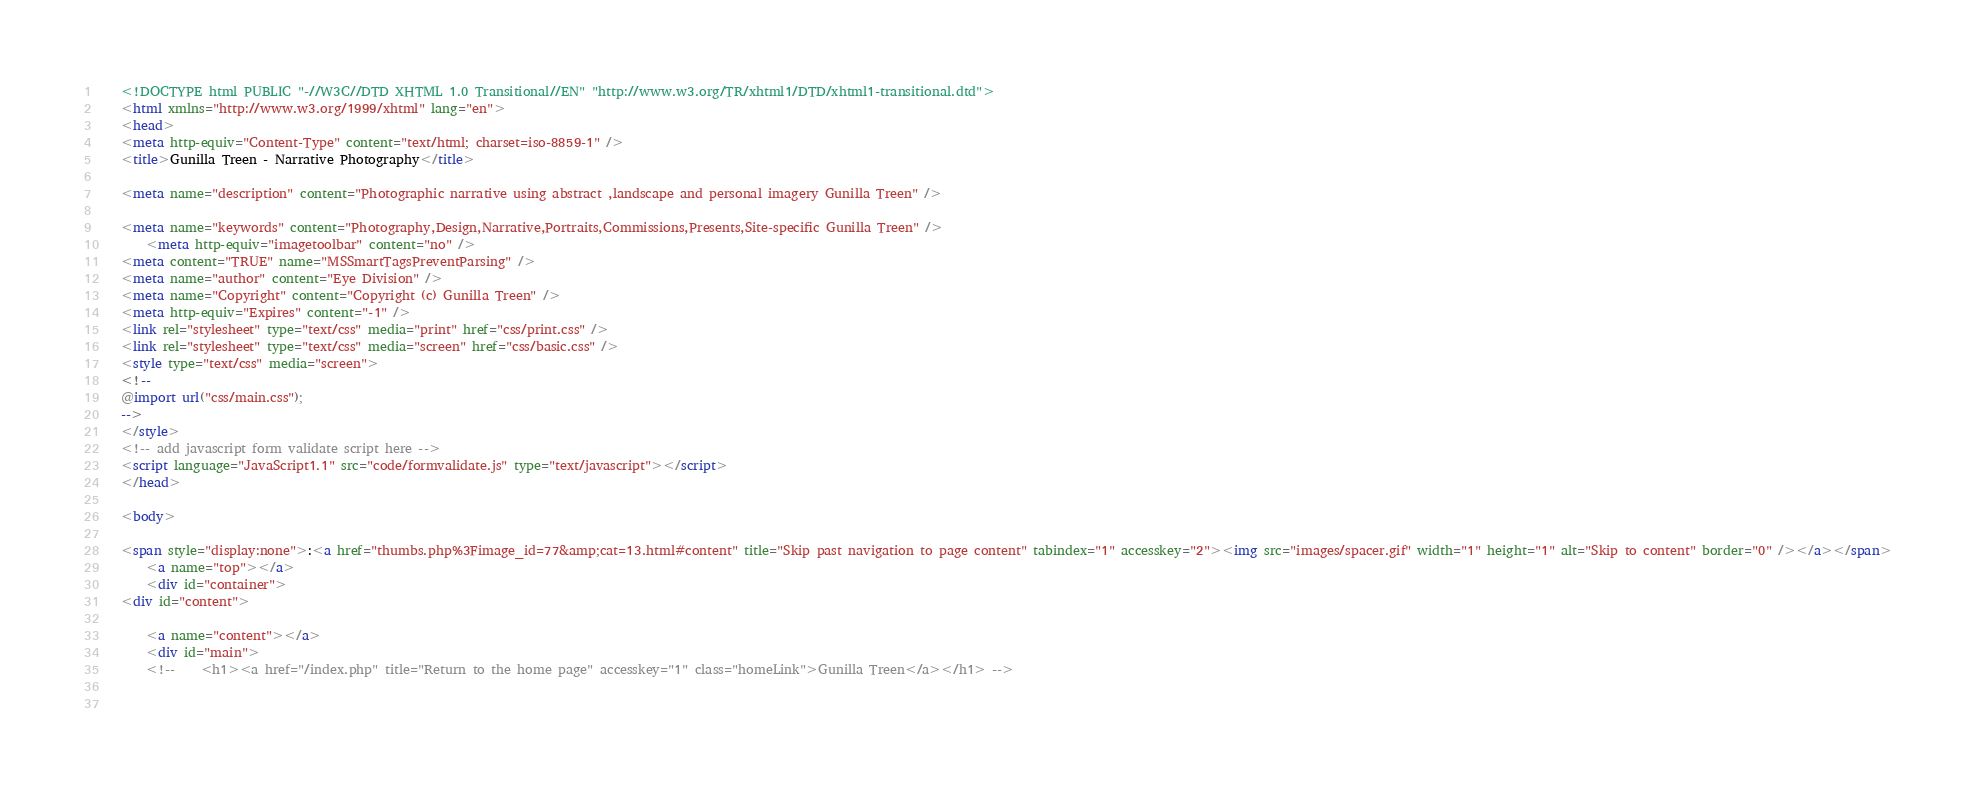Convert code to text. <code><loc_0><loc_0><loc_500><loc_500><_HTML_>	<!DOCTYPE html PUBLIC "-//W3C//DTD XHTML 1.0 Transitional//EN" "http://www.w3.org/TR/xhtml1/DTD/xhtml1-transitional.dtd">
	<html xmlns="http://www.w3.org/1999/xhtml" lang="en">
	<head>
	<meta http-equiv="Content-Type" content="text/html; charset=iso-8859-1" />
	<title>Gunilla Treen - Narrative Photography</title>
	 
	<meta name="description" content="Photographic narrative using abstract ,landscape and personal imagery Gunilla Treen" /> 
	 
	<meta name="keywords" content="Photography,Design,Narrative,Portraits,Commissions,Presents,Site-specific Gunilla Treen" />  
		<meta http-equiv="imagetoolbar" content="no" />
	<meta content="TRUE" name="MSSmartTagsPreventParsing" />
	<meta name="author" content="Eye Division" />
	<meta name="Copyright" content="Copyright (c) Gunilla Treen" />
	<meta http-equiv="Expires" content="-1" />
	<link rel="stylesheet" type="text/css" media="print" href="css/print.css" />
	<link rel="stylesheet" type="text/css" media="screen" href="css/basic.css" />
	<style type="text/css" media="screen">
	<!--
	@import url("css/main.css");
	-->
	</style>
	<!-- add javascript form validate script here -->
	<script language="JavaScript1.1" src="code/formvalidate.js" type="text/javascript"></script>
	</head>
	
	<body>
	
	<span style="display:none">:<a href="thumbs.php%3Fimage_id=77&amp;cat=13.html#content" title="Skip past navigation to page content" tabindex="1" accesskey="2"><img src="images/spacer.gif" width="1" height="1" alt="Skip to content" border="0" /></a></span>
		<a name="top"></a>
		<div id="container">
	<div id="content">
	
		<a name="content"></a>
		<div id="main">
		<!--	<h1><a href="/index.php" title="Return to the home page" accesskey="1" class="homeLink">Gunilla Treen</a></h1> -->
		
	</code> 